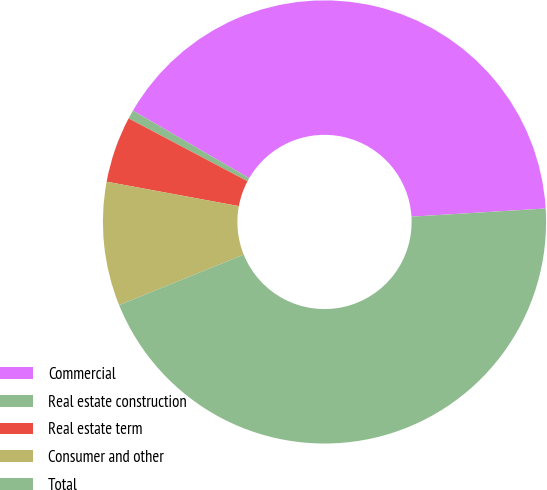Convert chart to OTSL. <chart><loc_0><loc_0><loc_500><loc_500><pie_chart><fcel>Commercial<fcel>Real estate construction<fcel>Real estate term<fcel>Consumer and other<fcel>Total<nl><fcel>40.66%<fcel>0.64%<fcel>4.83%<fcel>9.03%<fcel>44.85%<nl></chart> 